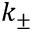Convert formula to latex. <formula><loc_0><loc_0><loc_500><loc_500>k _ { \pm }</formula> 